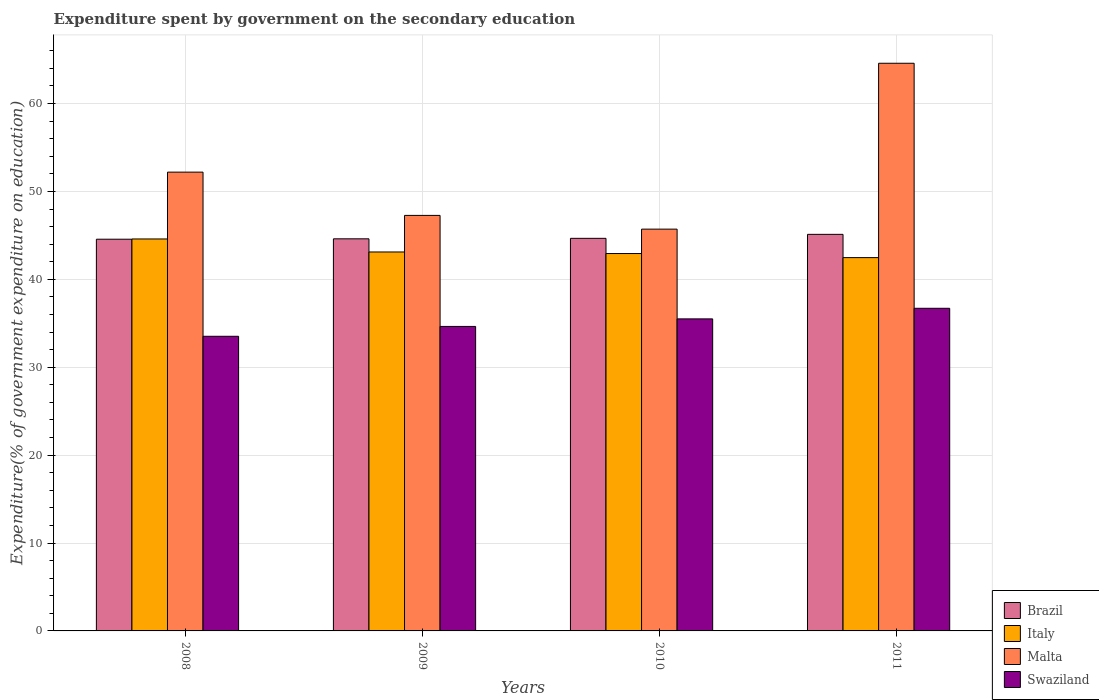Are the number of bars per tick equal to the number of legend labels?
Your response must be concise. Yes. Are the number of bars on each tick of the X-axis equal?
Provide a short and direct response. Yes. How many bars are there on the 4th tick from the left?
Ensure brevity in your answer.  4. How many bars are there on the 1st tick from the right?
Your answer should be compact. 4. What is the label of the 4th group of bars from the left?
Your response must be concise. 2011. In how many cases, is the number of bars for a given year not equal to the number of legend labels?
Your answer should be compact. 0. What is the expenditure spent by government on the secondary education in Swaziland in 2009?
Your answer should be compact. 34.64. Across all years, what is the maximum expenditure spent by government on the secondary education in Swaziland?
Your answer should be very brief. 36.71. Across all years, what is the minimum expenditure spent by government on the secondary education in Italy?
Provide a short and direct response. 42.47. In which year was the expenditure spent by government on the secondary education in Brazil maximum?
Make the answer very short. 2011. In which year was the expenditure spent by government on the secondary education in Malta minimum?
Your answer should be compact. 2010. What is the total expenditure spent by government on the secondary education in Italy in the graph?
Make the answer very short. 173.11. What is the difference between the expenditure spent by government on the secondary education in Brazil in 2009 and that in 2011?
Make the answer very short. -0.51. What is the difference between the expenditure spent by government on the secondary education in Swaziland in 2011 and the expenditure spent by government on the secondary education in Italy in 2010?
Provide a short and direct response. -6.23. What is the average expenditure spent by government on the secondary education in Swaziland per year?
Keep it short and to the point. 35.09. In the year 2010, what is the difference between the expenditure spent by government on the secondary education in Swaziland and expenditure spent by government on the secondary education in Brazil?
Your answer should be compact. -9.16. What is the ratio of the expenditure spent by government on the secondary education in Italy in 2010 to that in 2011?
Provide a succinct answer. 1.01. Is the difference between the expenditure spent by government on the secondary education in Swaziland in 2009 and 2010 greater than the difference between the expenditure spent by government on the secondary education in Brazil in 2009 and 2010?
Give a very brief answer. No. What is the difference between the highest and the second highest expenditure spent by government on the secondary education in Malta?
Make the answer very short. 12.39. What is the difference between the highest and the lowest expenditure spent by government on the secondary education in Swaziland?
Make the answer very short. 3.19. Is the sum of the expenditure spent by government on the secondary education in Italy in 2009 and 2011 greater than the maximum expenditure spent by government on the secondary education in Brazil across all years?
Provide a short and direct response. Yes. What does the 4th bar from the left in 2009 represents?
Offer a terse response. Swaziland. Is it the case that in every year, the sum of the expenditure spent by government on the secondary education in Italy and expenditure spent by government on the secondary education in Malta is greater than the expenditure spent by government on the secondary education in Brazil?
Ensure brevity in your answer.  Yes. Are all the bars in the graph horizontal?
Give a very brief answer. No. How many years are there in the graph?
Your answer should be very brief. 4. Are the values on the major ticks of Y-axis written in scientific E-notation?
Your answer should be very brief. No. Does the graph contain any zero values?
Offer a terse response. No. Does the graph contain grids?
Make the answer very short. Yes. How many legend labels are there?
Provide a short and direct response. 4. How are the legend labels stacked?
Your response must be concise. Vertical. What is the title of the graph?
Offer a terse response. Expenditure spent by government on the secondary education. Does "Cambodia" appear as one of the legend labels in the graph?
Your answer should be compact. No. What is the label or title of the X-axis?
Ensure brevity in your answer.  Years. What is the label or title of the Y-axis?
Your answer should be very brief. Expenditure(% of government expenditure on education). What is the Expenditure(% of government expenditure on education) of Brazil in 2008?
Keep it short and to the point. 44.56. What is the Expenditure(% of government expenditure on education) of Italy in 2008?
Ensure brevity in your answer.  44.59. What is the Expenditure(% of government expenditure on education) of Malta in 2008?
Your answer should be very brief. 52.2. What is the Expenditure(% of government expenditure on education) in Swaziland in 2008?
Make the answer very short. 33.52. What is the Expenditure(% of government expenditure on education) of Brazil in 2009?
Make the answer very short. 44.61. What is the Expenditure(% of government expenditure on education) of Italy in 2009?
Your answer should be compact. 43.11. What is the Expenditure(% of government expenditure on education) of Malta in 2009?
Provide a short and direct response. 47.27. What is the Expenditure(% of government expenditure on education) of Swaziland in 2009?
Your response must be concise. 34.64. What is the Expenditure(% of government expenditure on education) in Brazil in 2010?
Give a very brief answer. 44.66. What is the Expenditure(% of government expenditure on education) in Italy in 2010?
Your answer should be compact. 42.94. What is the Expenditure(% of government expenditure on education) of Malta in 2010?
Offer a very short reply. 45.71. What is the Expenditure(% of government expenditure on education) of Swaziland in 2010?
Ensure brevity in your answer.  35.5. What is the Expenditure(% of government expenditure on education) of Brazil in 2011?
Give a very brief answer. 45.12. What is the Expenditure(% of government expenditure on education) in Italy in 2011?
Your answer should be compact. 42.47. What is the Expenditure(% of government expenditure on education) of Malta in 2011?
Your response must be concise. 64.58. What is the Expenditure(% of government expenditure on education) in Swaziland in 2011?
Offer a terse response. 36.71. Across all years, what is the maximum Expenditure(% of government expenditure on education) of Brazil?
Provide a succinct answer. 45.12. Across all years, what is the maximum Expenditure(% of government expenditure on education) of Italy?
Offer a very short reply. 44.59. Across all years, what is the maximum Expenditure(% of government expenditure on education) of Malta?
Ensure brevity in your answer.  64.58. Across all years, what is the maximum Expenditure(% of government expenditure on education) in Swaziland?
Make the answer very short. 36.71. Across all years, what is the minimum Expenditure(% of government expenditure on education) in Brazil?
Your answer should be compact. 44.56. Across all years, what is the minimum Expenditure(% of government expenditure on education) of Italy?
Offer a very short reply. 42.47. Across all years, what is the minimum Expenditure(% of government expenditure on education) of Malta?
Give a very brief answer. 45.71. Across all years, what is the minimum Expenditure(% of government expenditure on education) of Swaziland?
Make the answer very short. 33.52. What is the total Expenditure(% of government expenditure on education) of Brazil in the graph?
Offer a terse response. 178.96. What is the total Expenditure(% of government expenditure on education) in Italy in the graph?
Your answer should be compact. 173.11. What is the total Expenditure(% of government expenditure on education) of Malta in the graph?
Your answer should be very brief. 209.76. What is the total Expenditure(% of government expenditure on education) of Swaziland in the graph?
Ensure brevity in your answer.  140.37. What is the difference between the Expenditure(% of government expenditure on education) in Brazil in 2008 and that in 2009?
Your response must be concise. -0.04. What is the difference between the Expenditure(% of government expenditure on education) in Italy in 2008 and that in 2009?
Offer a very short reply. 1.48. What is the difference between the Expenditure(% of government expenditure on education) of Malta in 2008 and that in 2009?
Keep it short and to the point. 4.92. What is the difference between the Expenditure(% of government expenditure on education) in Swaziland in 2008 and that in 2009?
Your response must be concise. -1.12. What is the difference between the Expenditure(% of government expenditure on education) of Brazil in 2008 and that in 2010?
Provide a succinct answer. -0.1. What is the difference between the Expenditure(% of government expenditure on education) in Italy in 2008 and that in 2010?
Provide a short and direct response. 1.66. What is the difference between the Expenditure(% of government expenditure on education) in Malta in 2008 and that in 2010?
Provide a short and direct response. 6.49. What is the difference between the Expenditure(% of government expenditure on education) in Swaziland in 2008 and that in 2010?
Make the answer very short. -1.98. What is the difference between the Expenditure(% of government expenditure on education) of Brazil in 2008 and that in 2011?
Ensure brevity in your answer.  -0.55. What is the difference between the Expenditure(% of government expenditure on education) in Italy in 2008 and that in 2011?
Your response must be concise. 2.12. What is the difference between the Expenditure(% of government expenditure on education) in Malta in 2008 and that in 2011?
Offer a terse response. -12.39. What is the difference between the Expenditure(% of government expenditure on education) in Swaziland in 2008 and that in 2011?
Provide a succinct answer. -3.19. What is the difference between the Expenditure(% of government expenditure on education) of Brazil in 2009 and that in 2010?
Offer a very short reply. -0.06. What is the difference between the Expenditure(% of government expenditure on education) of Italy in 2009 and that in 2010?
Provide a succinct answer. 0.18. What is the difference between the Expenditure(% of government expenditure on education) of Malta in 2009 and that in 2010?
Offer a very short reply. 1.56. What is the difference between the Expenditure(% of government expenditure on education) of Swaziland in 2009 and that in 2010?
Ensure brevity in your answer.  -0.86. What is the difference between the Expenditure(% of government expenditure on education) in Brazil in 2009 and that in 2011?
Your answer should be compact. -0.51. What is the difference between the Expenditure(% of government expenditure on education) of Italy in 2009 and that in 2011?
Provide a succinct answer. 0.64. What is the difference between the Expenditure(% of government expenditure on education) in Malta in 2009 and that in 2011?
Offer a terse response. -17.31. What is the difference between the Expenditure(% of government expenditure on education) in Swaziland in 2009 and that in 2011?
Ensure brevity in your answer.  -2.06. What is the difference between the Expenditure(% of government expenditure on education) of Brazil in 2010 and that in 2011?
Give a very brief answer. -0.45. What is the difference between the Expenditure(% of government expenditure on education) in Italy in 2010 and that in 2011?
Your response must be concise. 0.46. What is the difference between the Expenditure(% of government expenditure on education) in Malta in 2010 and that in 2011?
Your response must be concise. -18.87. What is the difference between the Expenditure(% of government expenditure on education) in Swaziland in 2010 and that in 2011?
Ensure brevity in your answer.  -1.21. What is the difference between the Expenditure(% of government expenditure on education) of Brazil in 2008 and the Expenditure(% of government expenditure on education) of Italy in 2009?
Your answer should be compact. 1.45. What is the difference between the Expenditure(% of government expenditure on education) of Brazil in 2008 and the Expenditure(% of government expenditure on education) of Malta in 2009?
Provide a succinct answer. -2.71. What is the difference between the Expenditure(% of government expenditure on education) in Brazil in 2008 and the Expenditure(% of government expenditure on education) in Swaziland in 2009?
Offer a very short reply. 9.92. What is the difference between the Expenditure(% of government expenditure on education) in Italy in 2008 and the Expenditure(% of government expenditure on education) in Malta in 2009?
Keep it short and to the point. -2.68. What is the difference between the Expenditure(% of government expenditure on education) in Italy in 2008 and the Expenditure(% of government expenditure on education) in Swaziland in 2009?
Ensure brevity in your answer.  9.95. What is the difference between the Expenditure(% of government expenditure on education) in Malta in 2008 and the Expenditure(% of government expenditure on education) in Swaziland in 2009?
Provide a succinct answer. 17.55. What is the difference between the Expenditure(% of government expenditure on education) in Brazil in 2008 and the Expenditure(% of government expenditure on education) in Italy in 2010?
Your answer should be compact. 1.63. What is the difference between the Expenditure(% of government expenditure on education) in Brazil in 2008 and the Expenditure(% of government expenditure on education) in Malta in 2010?
Keep it short and to the point. -1.15. What is the difference between the Expenditure(% of government expenditure on education) in Brazil in 2008 and the Expenditure(% of government expenditure on education) in Swaziland in 2010?
Provide a succinct answer. 9.06. What is the difference between the Expenditure(% of government expenditure on education) in Italy in 2008 and the Expenditure(% of government expenditure on education) in Malta in 2010?
Provide a short and direct response. -1.12. What is the difference between the Expenditure(% of government expenditure on education) of Italy in 2008 and the Expenditure(% of government expenditure on education) of Swaziland in 2010?
Your answer should be very brief. 9.09. What is the difference between the Expenditure(% of government expenditure on education) in Malta in 2008 and the Expenditure(% of government expenditure on education) in Swaziland in 2010?
Your response must be concise. 16.7. What is the difference between the Expenditure(% of government expenditure on education) of Brazil in 2008 and the Expenditure(% of government expenditure on education) of Italy in 2011?
Your answer should be compact. 2.09. What is the difference between the Expenditure(% of government expenditure on education) of Brazil in 2008 and the Expenditure(% of government expenditure on education) of Malta in 2011?
Keep it short and to the point. -20.02. What is the difference between the Expenditure(% of government expenditure on education) in Brazil in 2008 and the Expenditure(% of government expenditure on education) in Swaziland in 2011?
Make the answer very short. 7.86. What is the difference between the Expenditure(% of government expenditure on education) of Italy in 2008 and the Expenditure(% of government expenditure on education) of Malta in 2011?
Provide a short and direct response. -19.99. What is the difference between the Expenditure(% of government expenditure on education) in Italy in 2008 and the Expenditure(% of government expenditure on education) in Swaziland in 2011?
Provide a short and direct response. 7.89. What is the difference between the Expenditure(% of government expenditure on education) of Malta in 2008 and the Expenditure(% of government expenditure on education) of Swaziland in 2011?
Your response must be concise. 15.49. What is the difference between the Expenditure(% of government expenditure on education) of Brazil in 2009 and the Expenditure(% of government expenditure on education) of Italy in 2010?
Provide a short and direct response. 1.67. What is the difference between the Expenditure(% of government expenditure on education) in Brazil in 2009 and the Expenditure(% of government expenditure on education) in Malta in 2010?
Your answer should be compact. -1.1. What is the difference between the Expenditure(% of government expenditure on education) of Brazil in 2009 and the Expenditure(% of government expenditure on education) of Swaziland in 2010?
Give a very brief answer. 9.11. What is the difference between the Expenditure(% of government expenditure on education) of Italy in 2009 and the Expenditure(% of government expenditure on education) of Malta in 2010?
Your answer should be compact. -2.6. What is the difference between the Expenditure(% of government expenditure on education) of Italy in 2009 and the Expenditure(% of government expenditure on education) of Swaziland in 2010?
Offer a terse response. 7.61. What is the difference between the Expenditure(% of government expenditure on education) in Malta in 2009 and the Expenditure(% of government expenditure on education) in Swaziland in 2010?
Your answer should be very brief. 11.77. What is the difference between the Expenditure(% of government expenditure on education) of Brazil in 2009 and the Expenditure(% of government expenditure on education) of Italy in 2011?
Ensure brevity in your answer.  2.14. What is the difference between the Expenditure(% of government expenditure on education) in Brazil in 2009 and the Expenditure(% of government expenditure on education) in Malta in 2011?
Make the answer very short. -19.97. What is the difference between the Expenditure(% of government expenditure on education) of Brazil in 2009 and the Expenditure(% of government expenditure on education) of Swaziland in 2011?
Provide a succinct answer. 7.9. What is the difference between the Expenditure(% of government expenditure on education) of Italy in 2009 and the Expenditure(% of government expenditure on education) of Malta in 2011?
Your answer should be very brief. -21.47. What is the difference between the Expenditure(% of government expenditure on education) in Italy in 2009 and the Expenditure(% of government expenditure on education) in Swaziland in 2011?
Your answer should be very brief. 6.41. What is the difference between the Expenditure(% of government expenditure on education) of Malta in 2009 and the Expenditure(% of government expenditure on education) of Swaziland in 2011?
Make the answer very short. 10.57. What is the difference between the Expenditure(% of government expenditure on education) of Brazil in 2010 and the Expenditure(% of government expenditure on education) of Italy in 2011?
Your response must be concise. 2.19. What is the difference between the Expenditure(% of government expenditure on education) in Brazil in 2010 and the Expenditure(% of government expenditure on education) in Malta in 2011?
Provide a succinct answer. -19.92. What is the difference between the Expenditure(% of government expenditure on education) in Brazil in 2010 and the Expenditure(% of government expenditure on education) in Swaziland in 2011?
Give a very brief answer. 7.96. What is the difference between the Expenditure(% of government expenditure on education) in Italy in 2010 and the Expenditure(% of government expenditure on education) in Malta in 2011?
Ensure brevity in your answer.  -21.65. What is the difference between the Expenditure(% of government expenditure on education) in Italy in 2010 and the Expenditure(% of government expenditure on education) in Swaziland in 2011?
Give a very brief answer. 6.23. What is the difference between the Expenditure(% of government expenditure on education) of Malta in 2010 and the Expenditure(% of government expenditure on education) of Swaziland in 2011?
Give a very brief answer. 9. What is the average Expenditure(% of government expenditure on education) in Brazil per year?
Your answer should be compact. 44.74. What is the average Expenditure(% of government expenditure on education) of Italy per year?
Give a very brief answer. 43.28. What is the average Expenditure(% of government expenditure on education) in Malta per year?
Provide a succinct answer. 52.44. What is the average Expenditure(% of government expenditure on education) in Swaziland per year?
Your response must be concise. 35.09. In the year 2008, what is the difference between the Expenditure(% of government expenditure on education) of Brazil and Expenditure(% of government expenditure on education) of Italy?
Give a very brief answer. -0.03. In the year 2008, what is the difference between the Expenditure(% of government expenditure on education) in Brazil and Expenditure(% of government expenditure on education) in Malta?
Ensure brevity in your answer.  -7.63. In the year 2008, what is the difference between the Expenditure(% of government expenditure on education) of Brazil and Expenditure(% of government expenditure on education) of Swaziland?
Ensure brevity in your answer.  11.04. In the year 2008, what is the difference between the Expenditure(% of government expenditure on education) in Italy and Expenditure(% of government expenditure on education) in Malta?
Offer a very short reply. -7.6. In the year 2008, what is the difference between the Expenditure(% of government expenditure on education) in Italy and Expenditure(% of government expenditure on education) in Swaziland?
Provide a short and direct response. 11.07. In the year 2008, what is the difference between the Expenditure(% of government expenditure on education) in Malta and Expenditure(% of government expenditure on education) in Swaziland?
Offer a very short reply. 18.68. In the year 2009, what is the difference between the Expenditure(% of government expenditure on education) of Brazil and Expenditure(% of government expenditure on education) of Italy?
Keep it short and to the point. 1.5. In the year 2009, what is the difference between the Expenditure(% of government expenditure on education) in Brazil and Expenditure(% of government expenditure on education) in Malta?
Ensure brevity in your answer.  -2.66. In the year 2009, what is the difference between the Expenditure(% of government expenditure on education) in Brazil and Expenditure(% of government expenditure on education) in Swaziland?
Make the answer very short. 9.97. In the year 2009, what is the difference between the Expenditure(% of government expenditure on education) in Italy and Expenditure(% of government expenditure on education) in Malta?
Make the answer very short. -4.16. In the year 2009, what is the difference between the Expenditure(% of government expenditure on education) in Italy and Expenditure(% of government expenditure on education) in Swaziland?
Your answer should be compact. 8.47. In the year 2009, what is the difference between the Expenditure(% of government expenditure on education) in Malta and Expenditure(% of government expenditure on education) in Swaziland?
Offer a terse response. 12.63. In the year 2010, what is the difference between the Expenditure(% of government expenditure on education) in Brazil and Expenditure(% of government expenditure on education) in Italy?
Give a very brief answer. 1.73. In the year 2010, what is the difference between the Expenditure(% of government expenditure on education) of Brazil and Expenditure(% of government expenditure on education) of Malta?
Your response must be concise. -1.05. In the year 2010, what is the difference between the Expenditure(% of government expenditure on education) in Brazil and Expenditure(% of government expenditure on education) in Swaziland?
Offer a very short reply. 9.16. In the year 2010, what is the difference between the Expenditure(% of government expenditure on education) in Italy and Expenditure(% of government expenditure on education) in Malta?
Make the answer very short. -2.78. In the year 2010, what is the difference between the Expenditure(% of government expenditure on education) of Italy and Expenditure(% of government expenditure on education) of Swaziland?
Offer a terse response. 7.44. In the year 2010, what is the difference between the Expenditure(% of government expenditure on education) of Malta and Expenditure(% of government expenditure on education) of Swaziland?
Make the answer very short. 10.21. In the year 2011, what is the difference between the Expenditure(% of government expenditure on education) of Brazil and Expenditure(% of government expenditure on education) of Italy?
Your answer should be very brief. 2.65. In the year 2011, what is the difference between the Expenditure(% of government expenditure on education) of Brazil and Expenditure(% of government expenditure on education) of Malta?
Your response must be concise. -19.46. In the year 2011, what is the difference between the Expenditure(% of government expenditure on education) in Brazil and Expenditure(% of government expenditure on education) in Swaziland?
Ensure brevity in your answer.  8.41. In the year 2011, what is the difference between the Expenditure(% of government expenditure on education) in Italy and Expenditure(% of government expenditure on education) in Malta?
Offer a terse response. -22.11. In the year 2011, what is the difference between the Expenditure(% of government expenditure on education) of Italy and Expenditure(% of government expenditure on education) of Swaziland?
Make the answer very short. 5.76. In the year 2011, what is the difference between the Expenditure(% of government expenditure on education) in Malta and Expenditure(% of government expenditure on education) in Swaziland?
Your response must be concise. 27.88. What is the ratio of the Expenditure(% of government expenditure on education) in Italy in 2008 to that in 2009?
Offer a very short reply. 1.03. What is the ratio of the Expenditure(% of government expenditure on education) of Malta in 2008 to that in 2009?
Offer a very short reply. 1.1. What is the ratio of the Expenditure(% of government expenditure on education) in Swaziland in 2008 to that in 2009?
Give a very brief answer. 0.97. What is the ratio of the Expenditure(% of government expenditure on education) in Italy in 2008 to that in 2010?
Provide a short and direct response. 1.04. What is the ratio of the Expenditure(% of government expenditure on education) of Malta in 2008 to that in 2010?
Offer a very short reply. 1.14. What is the ratio of the Expenditure(% of government expenditure on education) in Swaziland in 2008 to that in 2010?
Keep it short and to the point. 0.94. What is the ratio of the Expenditure(% of government expenditure on education) of Malta in 2008 to that in 2011?
Ensure brevity in your answer.  0.81. What is the ratio of the Expenditure(% of government expenditure on education) of Swaziland in 2008 to that in 2011?
Offer a terse response. 0.91. What is the ratio of the Expenditure(% of government expenditure on education) in Brazil in 2009 to that in 2010?
Provide a succinct answer. 1. What is the ratio of the Expenditure(% of government expenditure on education) in Italy in 2009 to that in 2010?
Offer a very short reply. 1. What is the ratio of the Expenditure(% of government expenditure on education) of Malta in 2009 to that in 2010?
Offer a very short reply. 1.03. What is the ratio of the Expenditure(% of government expenditure on education) in Swaziland in 2009 to that in 2010?
Your answer should be compact. 0.98. What is the ratio of the Expenditure(% of government expenditure on education) in Brazil in 2009 to that in 2011?
Provide a succinct answer. 0.99. What is the ratio of the Expenditure(% of government expenditure on education) of Italy in 2009 to that in 2011?
Keep it short and to the point. 1.02. What is the ratio of the Expenditure(% of government expenditure on education) in Malta in 2009 to that in 2011?
Provide a short and direct response. 0.73. What is the ratio of the Expenditure(% of government expenditure on education) in Swaziland in 2009 to that in 2011?
Ensure brevity in your answer.  0.94. What is the ratio of the Expenditure(% of government expenditure on education) of Brazil in 2010 to that in 2011?
Provide a short and direct response. 0.99. What is the ratio of the Expenditure(% of government expenditure on education) of Italy in 2010 to that in 2011?
Offer a terse response. 1.01. What is the ratio of the Expenditure(% of government expenditure on education) of Malta in 2010 to that in 2011?
Provide a short and direct response. 0.71. What is the ratio of the Expenditure(% of government expenditure on education) in Swaziland in 2010 to that in 2011?
Your response must be concise. 0.97. What is the difference between the highest and the second highest Expenditure(% of government expenditure on education) of Brazil?
Make the answer very short. 0.45. What is the difference between the highest and the second highest Expenditure(% of government expenditure on education) in Italy?
Your answer should be very brief. 1.48. What is the difference between the highest and the second highest Expenditure(% of government expenditure on education) of Malta?
Offer a very short reply. 12.39. What is the difference between the highest and the second highest Expenditure(% of government expenditure on education) of Swaziland?
Make the answer very short. 1.21. What is the difference between the highest and the lowest Expenditure(% of government expenditure on education) in Brazil?
Offer a terse response. 0.55. What is the difference between the highest and the lowest Expenditure(% of government expenditure on education) of Italy?
Your answer should be compact. 2.12. What is the difference between the highest and the lowest Expenditure(% of government expenditure on education) in Malta?
Give a very brief answer. 18.87. What is the difference between the highest and the lowest Expenditure(% of government expenditure on education) of Swaziland?
Your response must be concise. 3.19. 